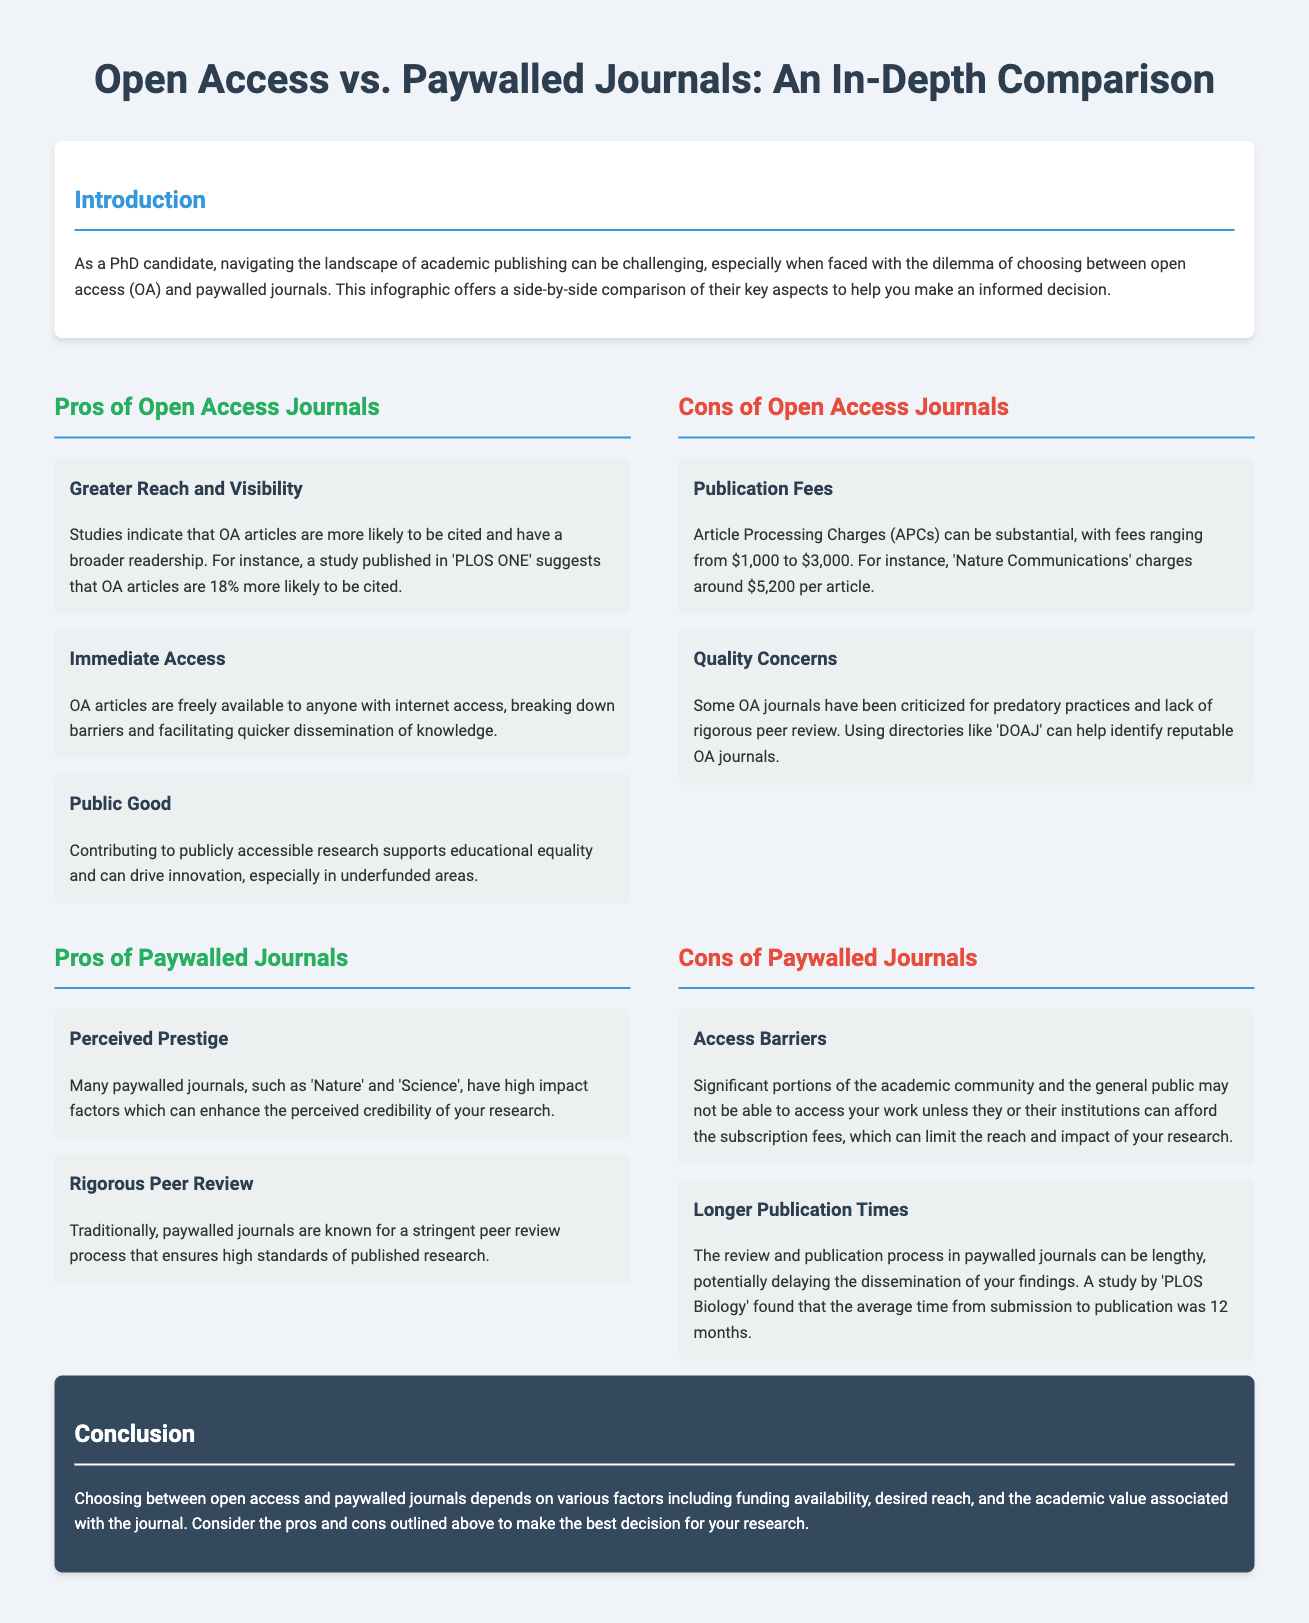What is the article processing charge range for open access journals? The document states that Article Processing Charges (APCs) can be substantial, with fees ranging from $1,000 to $3,000.
Answer: $1,000 to $3,000 Which journal charges around $5,200 per article? The document specifies that 'Nature Communications' charges around $5,200 per article.
Answer: Nature Communications What is a benefit of publishing in open access journals regarding citations? The infographic mentions that OA articles are 18% more likely to be cited.
Answer: 18% What is one concern regarding the quality of open access journals? The document indicates that some OA journals have been criticized for predatory practices and lack of rigorous peer review.
Answer: Quality concerns What is a con of paywalled journals related to access? It states that significant portions of the academic community and the general public may not be able to access your work unless they or their institutions can afford the subscription fees.
Answer: Access barriers What is the average time from submission to publication in paywalled journals? A study by 'PLOS Biology' found that the average time was 12 months.
Answer: 12 months What key aspect is noted in the introduction regarding the document's purpose? The introduction mentions that this infographic offers a side-by-side comparison of key aspects to help make an informed decision.
Answer: Informed decision What does the conclusion suggest is essential to consider when choosing between publishing options? The conclusion emphasizes considering various factors, including funding availability and desired reach.
Answer: Various factors 